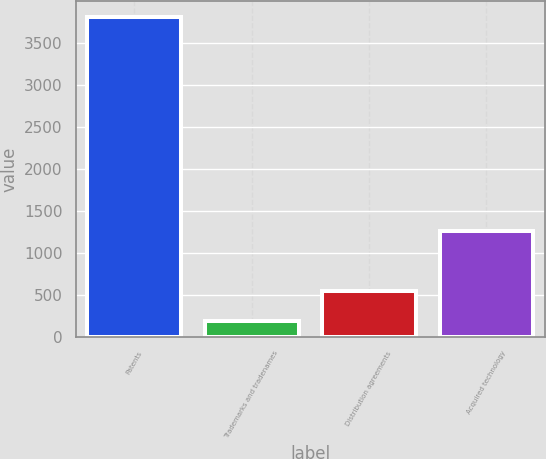Convert chart to OTSL. <chart><loc_0><loc_0><loc_500><loc_500><bar_chart><fcel>Patents<fcel>Trademarks and tradenames<fcel>Distribution agreements<fcel>Acquired technology<nl><fcel>3800<fcel>185<fcel>546.5<fcel>1257<nl></chart> 